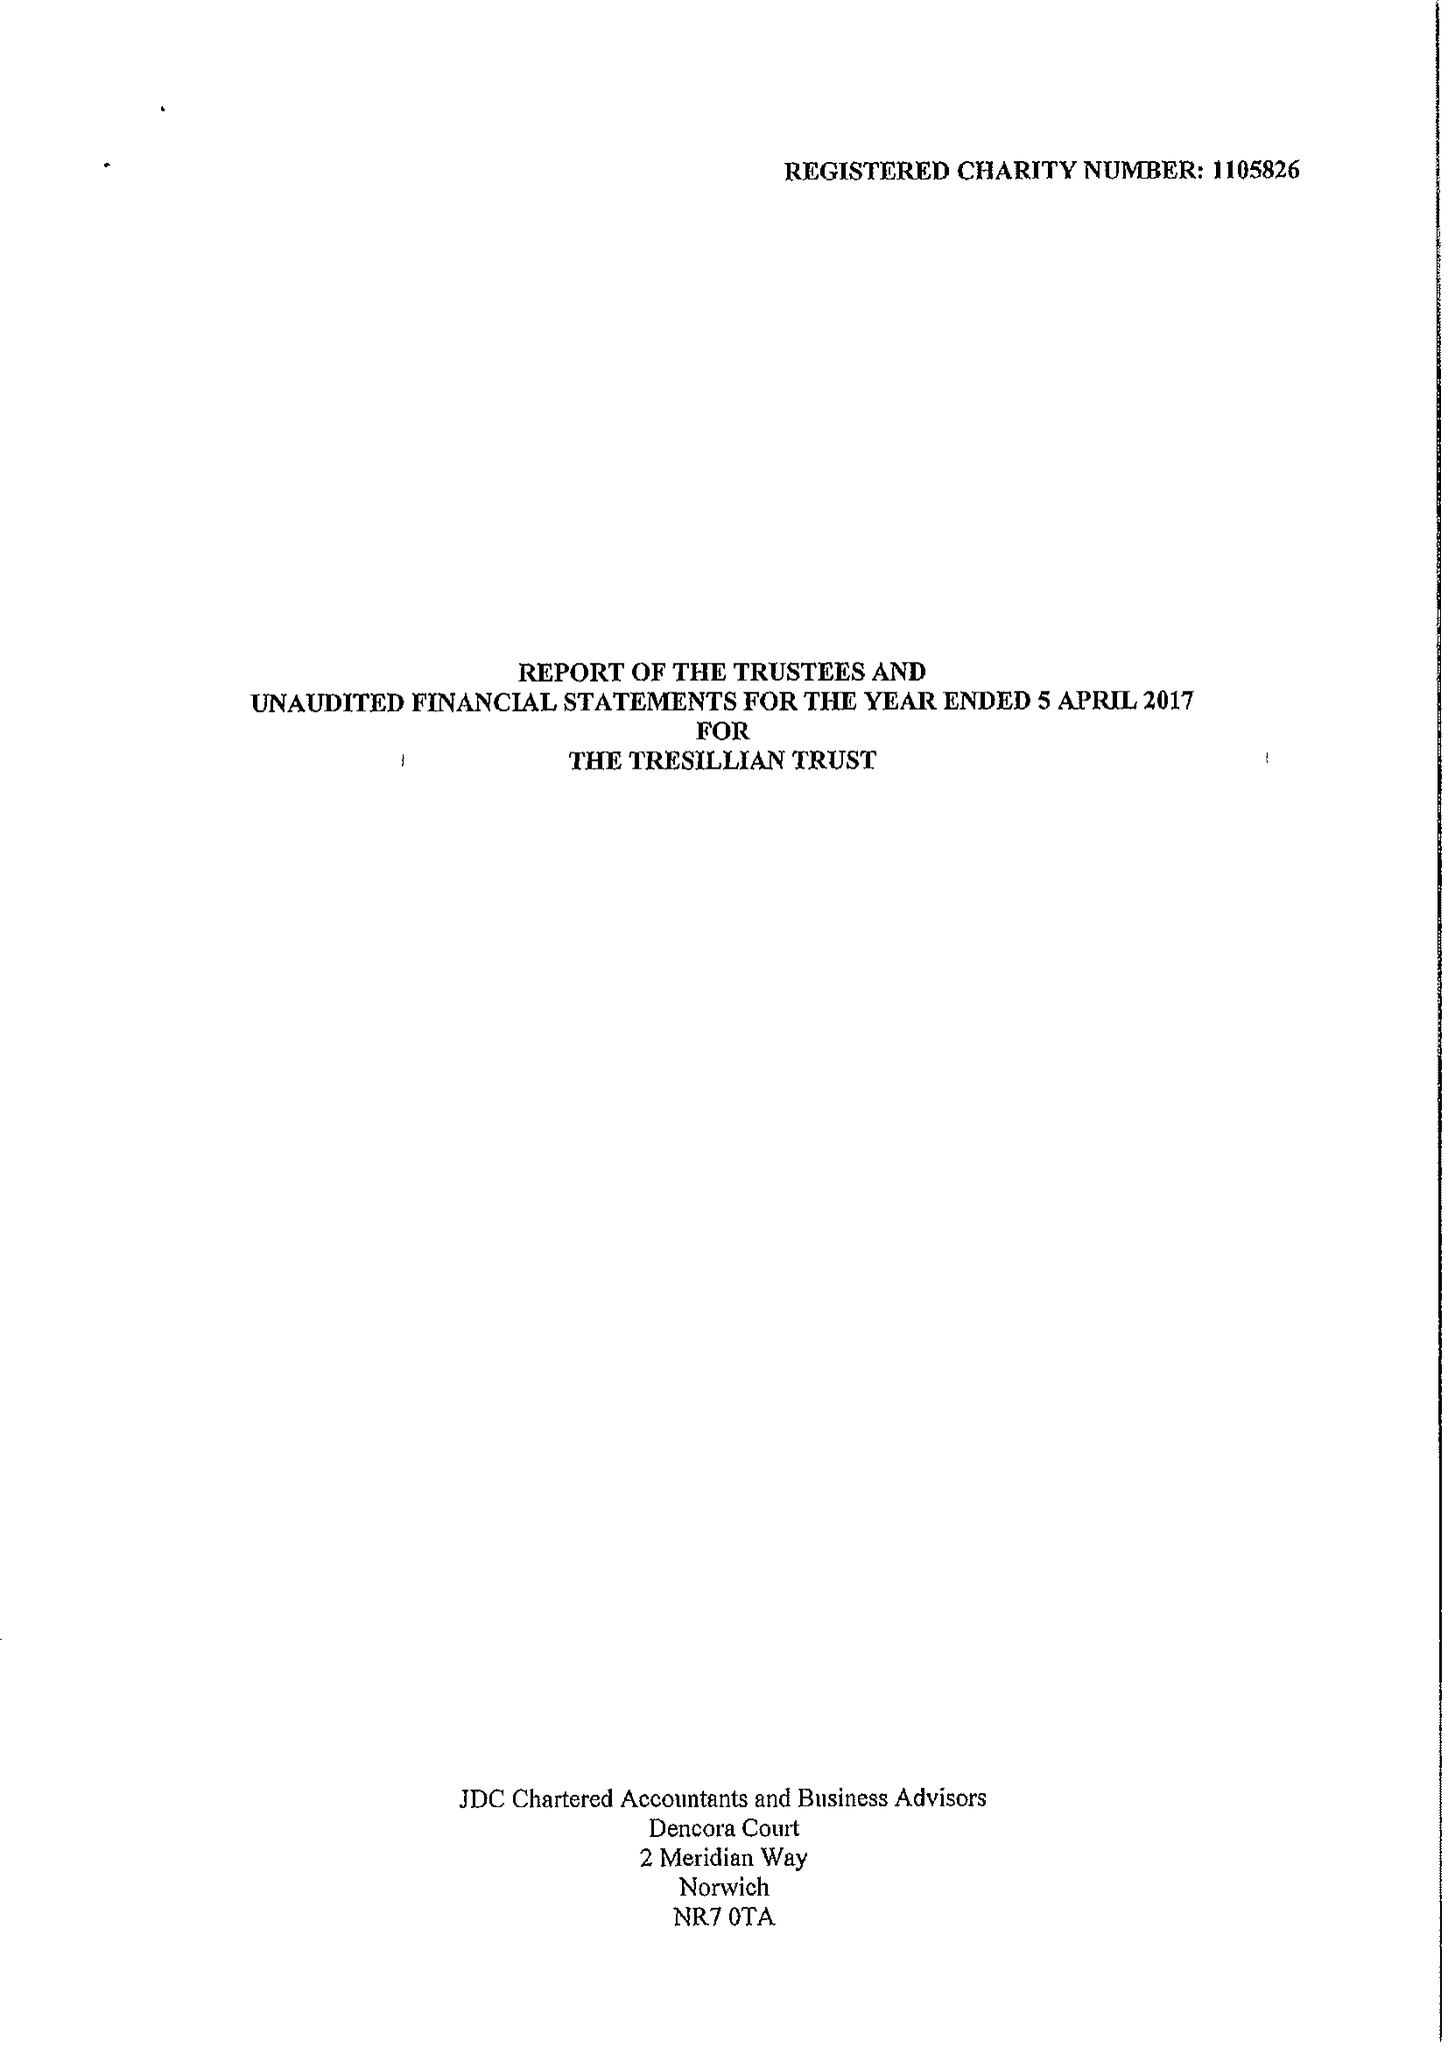What is the value for the charity_name?
Answer the question using a single word or phrase. The Tresillian Trust 